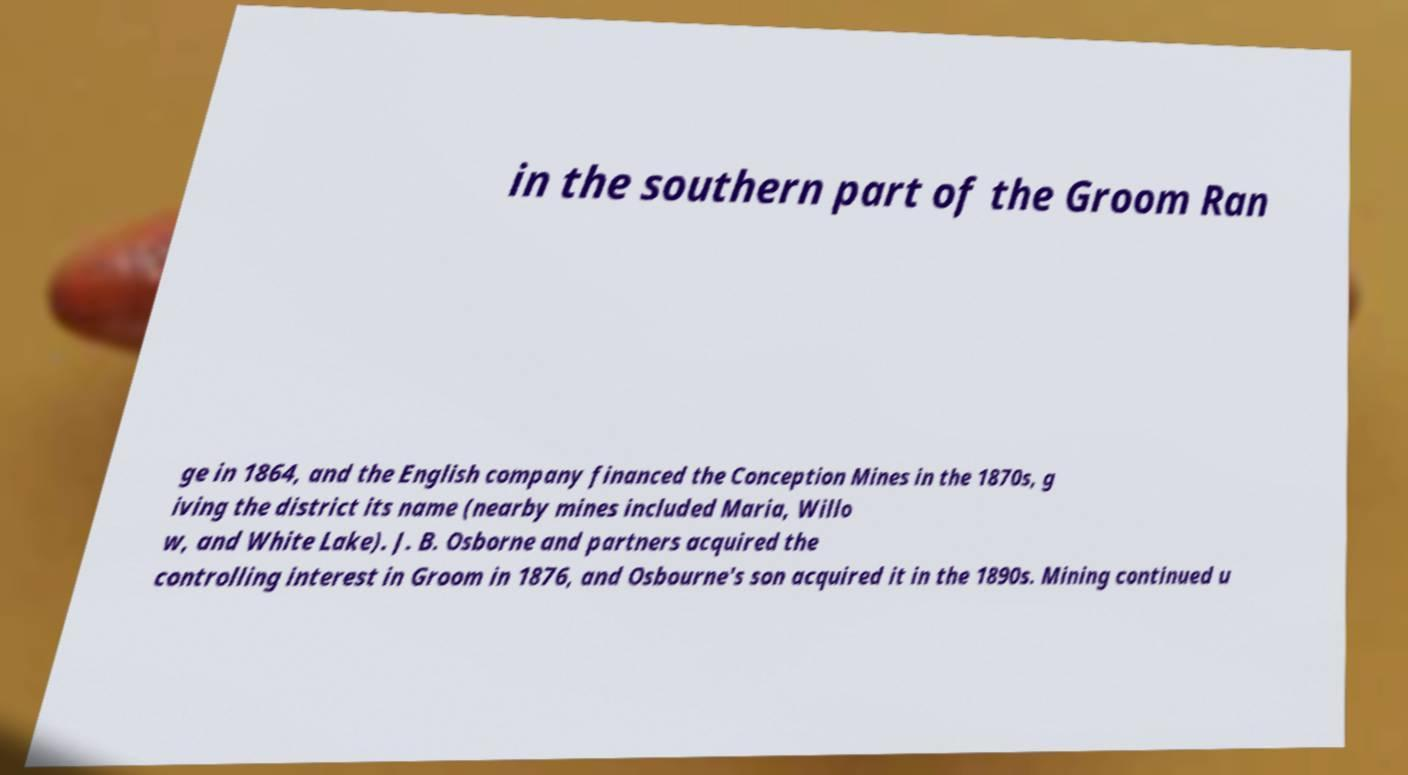Please identify and transcribe the text found in this image. in the southern part of the Groom Ran ge in 1864, and the English company financed the Conception Mines in the 1870s, g iving the district its name (nearby mines included Maria, Willo w, and White Lake). J. B. Osborne and partners acquired the controlling interest in Groom in 1876, and Osbourne's son acquired it in the 1890s. Mining continued u 